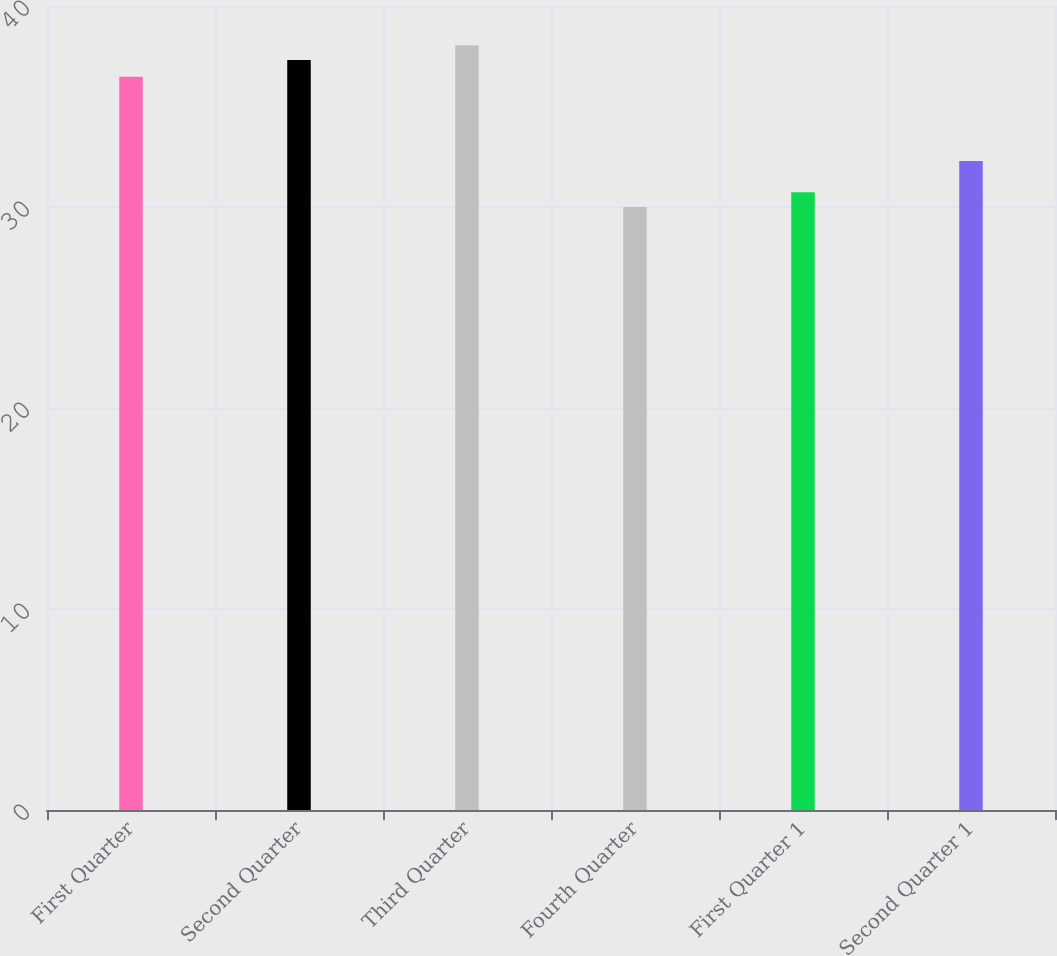Convert chart. <chart><loc_0><loc_0><loc_500><loc_500><bar_chart><fcel>First Quarter<fcel>Second Quarter<fcel>Third Quarter<fcel>Fourth Quarter<fcel>First Quarter 1<fcel>Second Quarter 1<nl><fcel>36.48<fcel>37.31<fcel>38.05<fcel>30<fcel>30.74<fcel>32.29<nl></chart> 